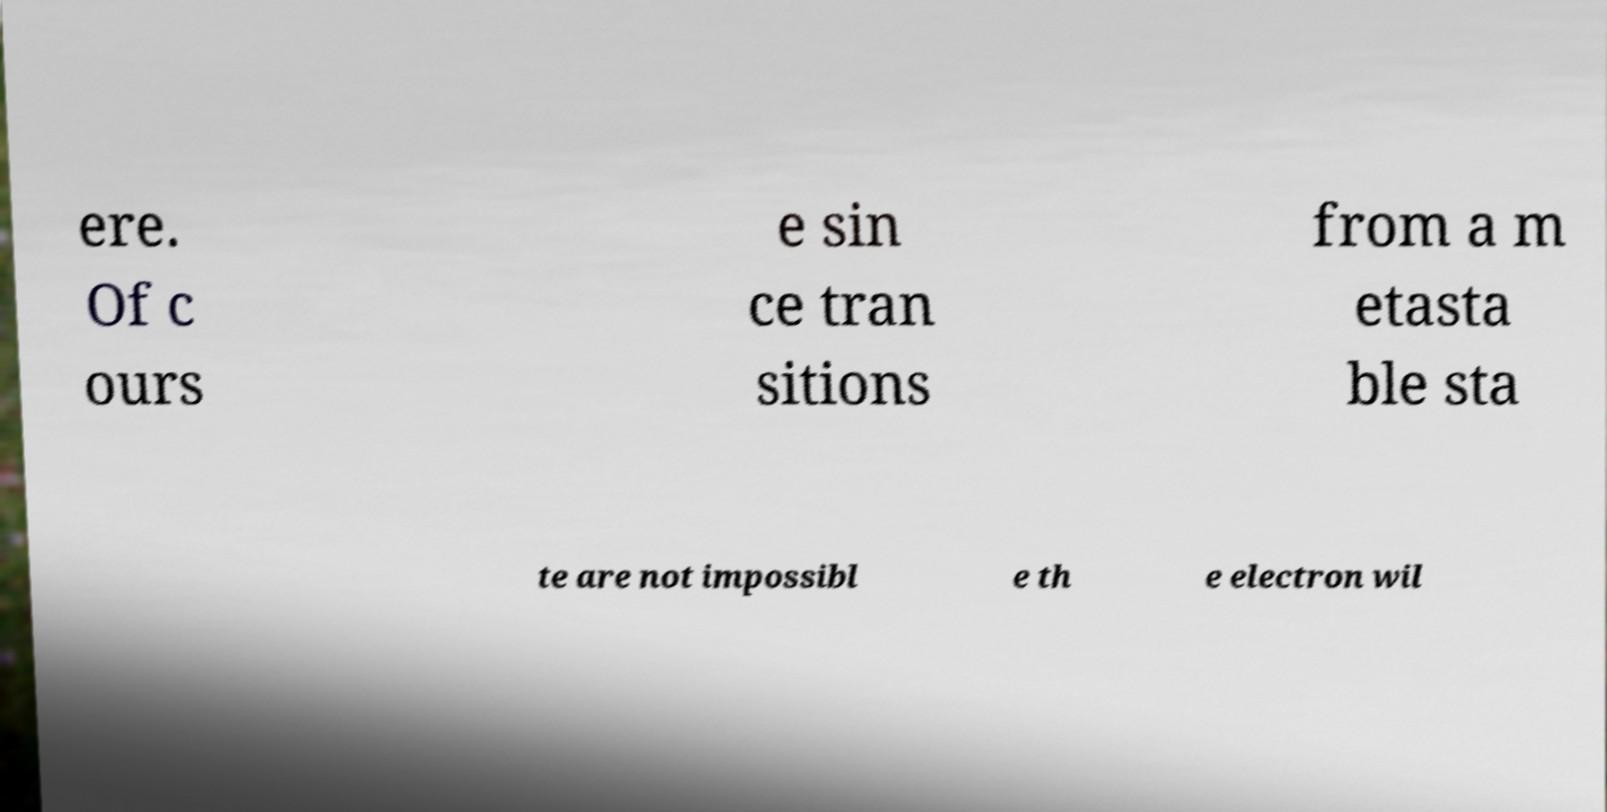Could you extract and type out the text from this image? ere. Of c ours e sin ce tran sitions from a m etasta ble sta te are not impossibl e th e electron wil 